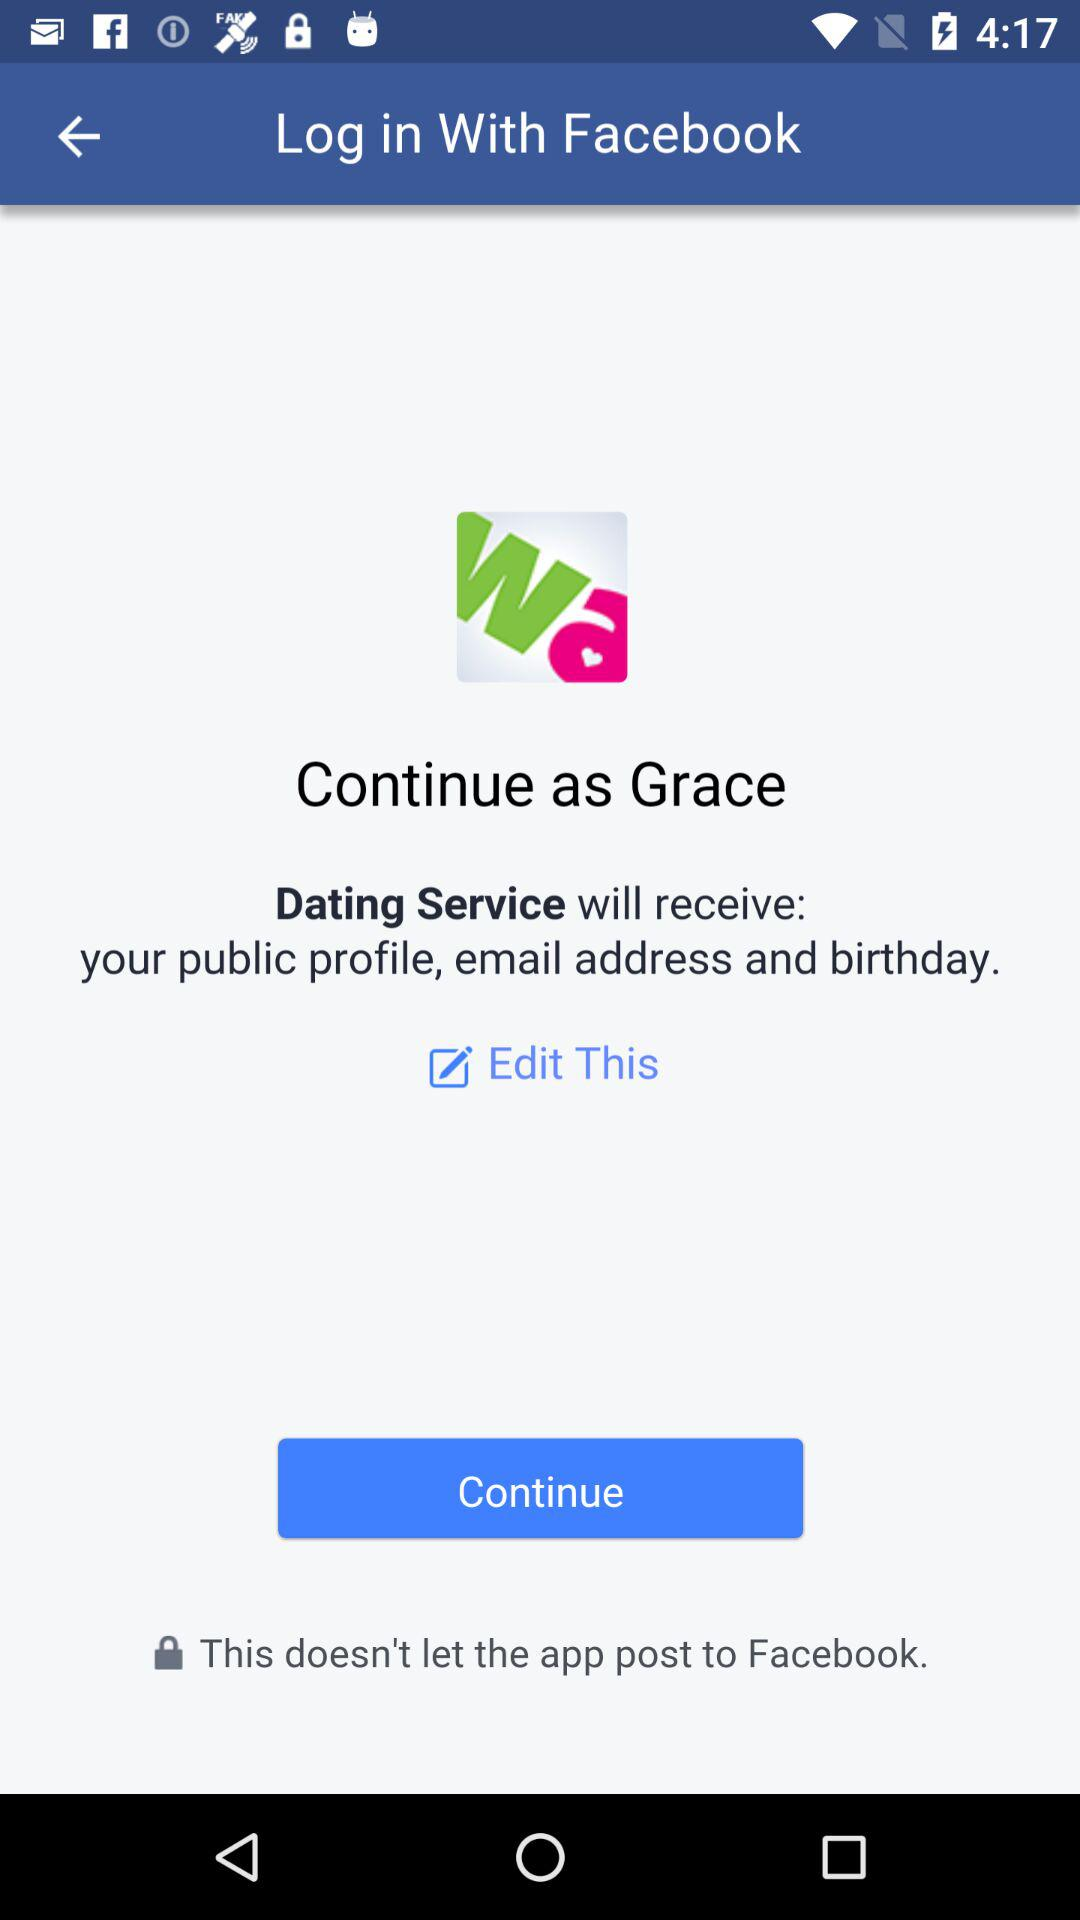What application will receive the public figure, birthday and email address? The application is "Dating Service". 